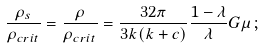Convert formula to latex. <formula><loc_0><loc_0><loc_500><loc_500>\frac { \rho _ { s } } { \rho _ { c r i t } } = \frac { \rho } { \rho _ { c r i t } } = \frac { 3 2 \pi } { 3 k ( k + c ) } \frac { 1 - \lambda } { \lambda } G \mu \, ;</formula> 